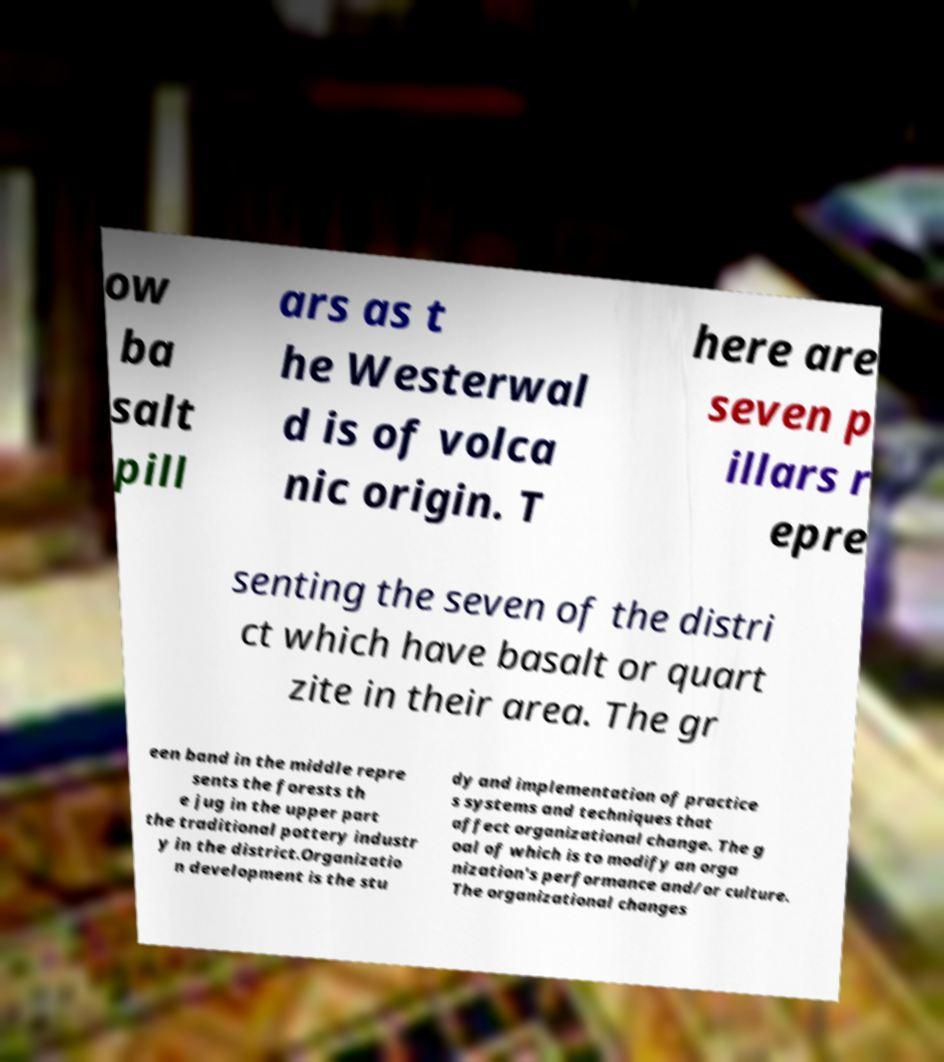For documentation purposes, I need the text within this image transcribed. Could you provide that? ow ba salt pill ars as t he Westerwal d is of volca nic origin. T here are seven p illars r epre senting the seven of the distri ct which have basalt or quart zite in their area. The gr een band in the middle repre sents the forests th e jug in the upper part the traditional pottery industr y in the district.Organizatio n development is the stu dy and implementation of practice s systems and techniques that affect organizational change. The g oal of which is to modify an orga nization's performance and/or culture. The organizational changes 